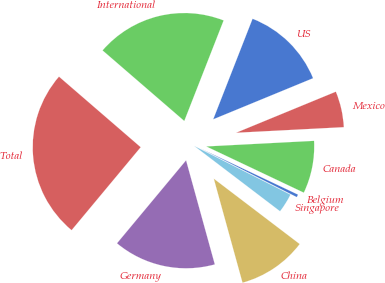Convert chart. <chart><loc_0><loc_0><loc_500><loc_500><pie_chart><fcel>US<fcel>International<fcel>Total<fcel>Germany<fcel>China<fcel>Singapore<fcel>Belgium<fcel>Canada<fcel>Mexico<nl><fcel>12.85%<fcel>19.6%<fcel>25.29%<fcel>15.34%<fcel>10.36%<fcel>2.9%<fcel>0.41%<fcel>7.87%<fcel>5.39%<nl></chart> 